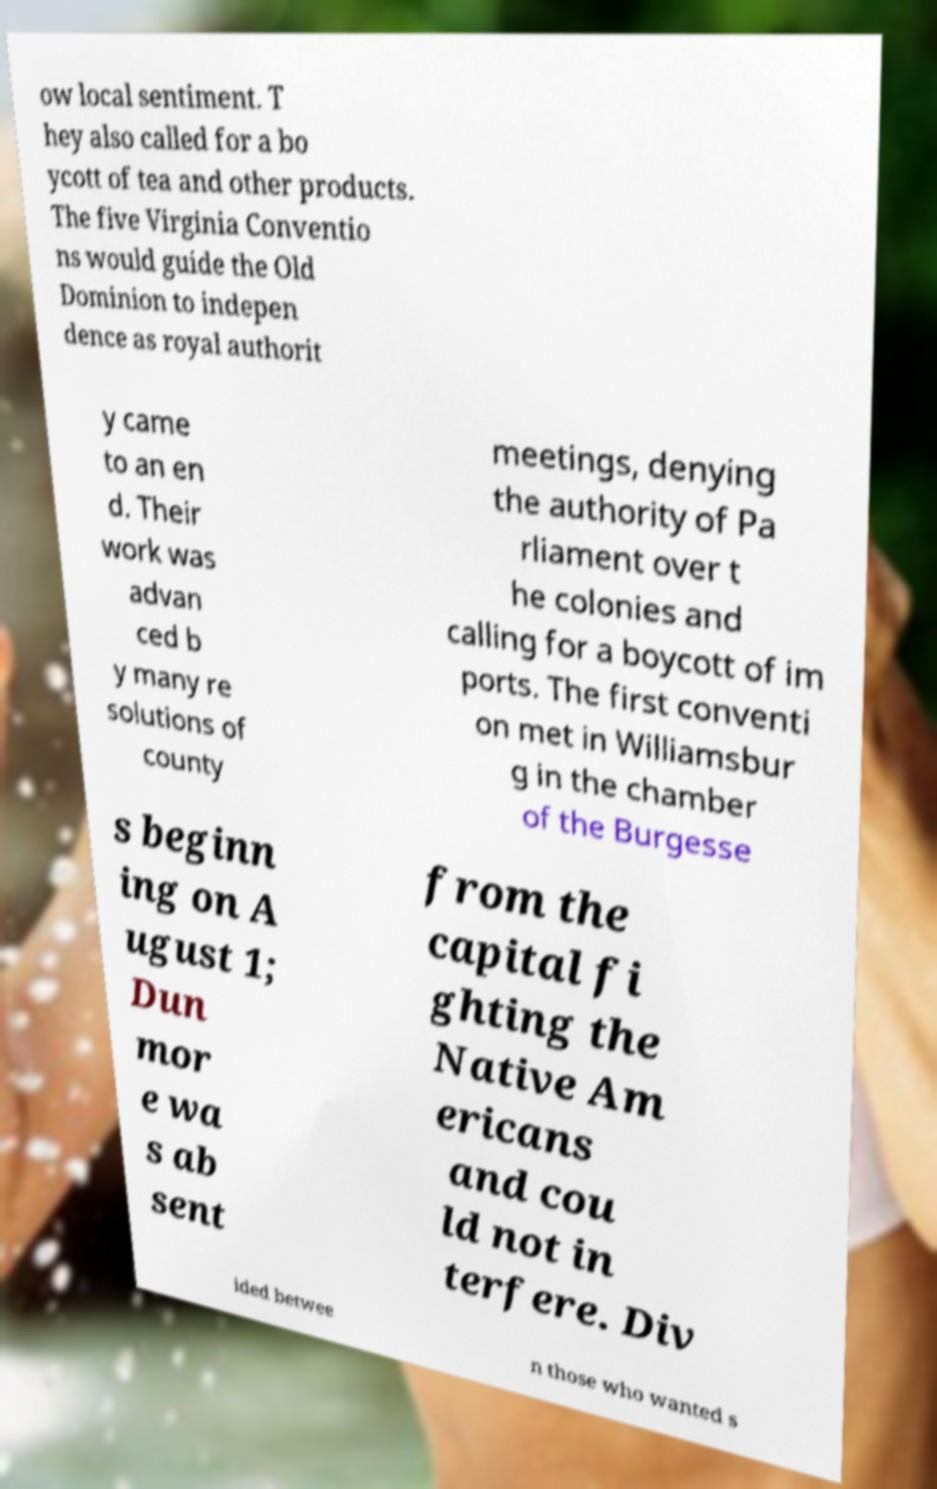Please identify and transcribe the text found in this image. ow local sentiment. T hey also called for a bo ycott of tea and other products. The five Virginia Conventio ns would guide the Old Dominion to indepen dence as royal authorit y came to an en d. Their work was advan ced b y many re solutions of county meetings, denying the authority of Pa rliament over t he colonies and calling for a boycott of im ports. The first conventi on met in Williamsbur g in the chamber of the Burgesse s beginn ing on A ugust 1; Dun mor e wa s ab sent from the capital fi ghting the Native Am ericans and cou ld not in terfere. Div ided betwee n those who wanted s 